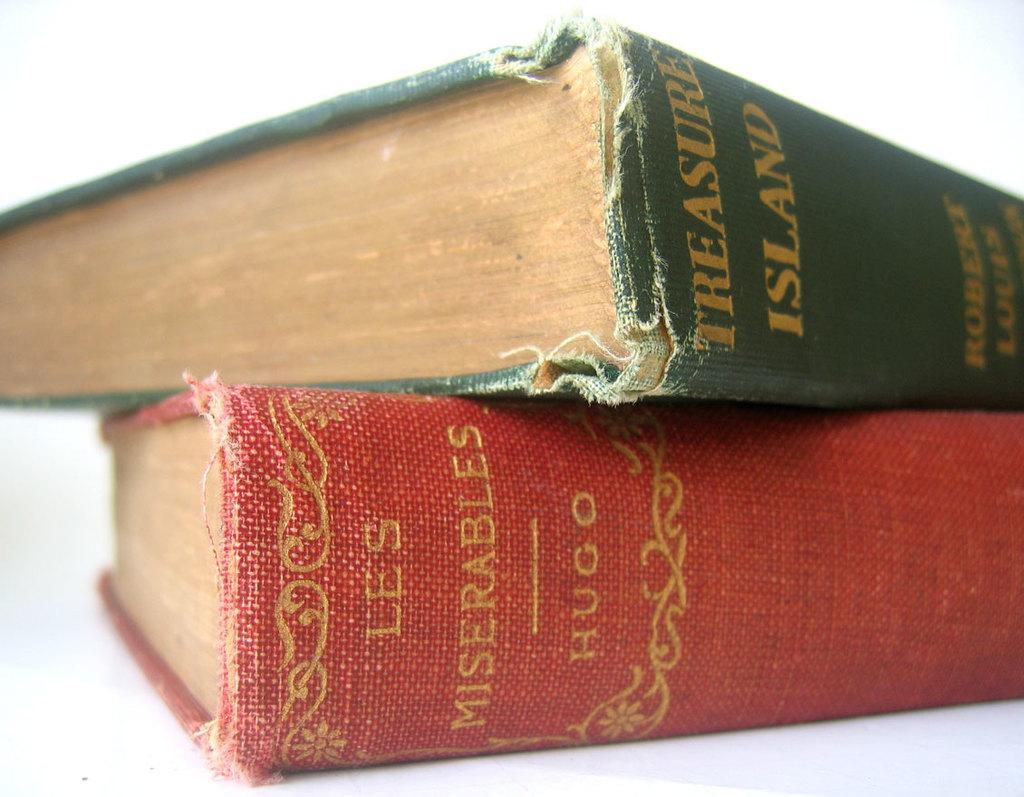<image>
Give a short and clear explanation of the subsequent image. The classic book Treasure Island lies atop the Hugo classic called Les Miserables. 